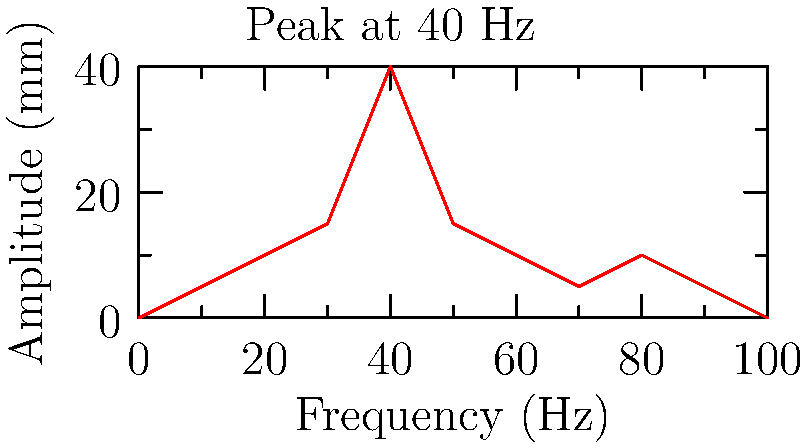As a manufacturing plant manager, you're analyzing a vibration frequency spectrum from a machine in your production line. The graph shows a significant peak at 40 Hz. What could be a likely cause of this vibration, and what immediate action should you take to address it? To analyze this situation and determine the appropriate action, let's follow these steps:

1. Interpret the graph:
   - The x-axis represents frequency in Hz (cycles per second)
   - The y-axis represents amplitude in mm (magnitude of vibration)
   - There's a prominent peak at 40 Hz

2. Understand the significance of 40 Hz:
   - In many industrial machines, 40 Hz corresponds to 2400 RPM (Revolutions Per Minute)
   - Calculate: $40 \text{ Hz} \times 60 \text{ s/min} = 2400 \text{ RPM}$

3. Identify potential causes:
   - This frequency often indicates an imbalance in rotating components
   - Common culprits include:
     a) Impeller or fan imbalance
     b) Misaligned shafts or couplings
     c) Bent shaft
     d) Loose mounting bolts

4. Determine immediate action:
   - The high amplitude suggests this is a significant issue that needs prompt attention
   - To prevent potential damage and reduce noise, the machine should be shut down
   - A thorough inspection of rotating components at 2400 RPM is necessary

5. Plan for further analysis:
   - After shutdown, conduct a detailed inspection of the machine
   - Use balancing equipment to check for and correct any imbalances
   - Verify alignment of shafts and couplings
   - Check for loose or worn components

By shutting down the machine and inspecting the components operating at 2400 RPM, you can identify and address the root cause of the vibration, potentially preventing costly damage and reducing noise in your production process.
Answer: Shut down the machine and inspect components operating at 2400 RPM for imbalance or misalignment. 